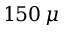Convert formula to latex. <formula><loc_0><loc_0><loc_500><loc_500>1 5 0 \, \mu</formula> 